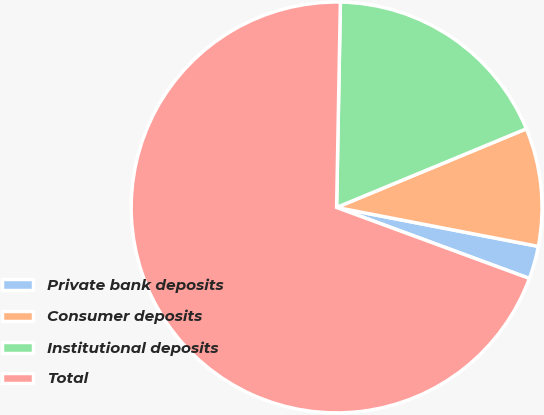Convert chart. <chart><loc_0><loc_0><loc_500><loc_500><pie_chart><fcel>Private bank deposits<fcel>Consumer deposits<fcel>Institutional deposits<fcel>Total<nl><fcel>2.58%<fcel>9.29%<fcel>18.45%<fcel>69.67%<nl></chart> 